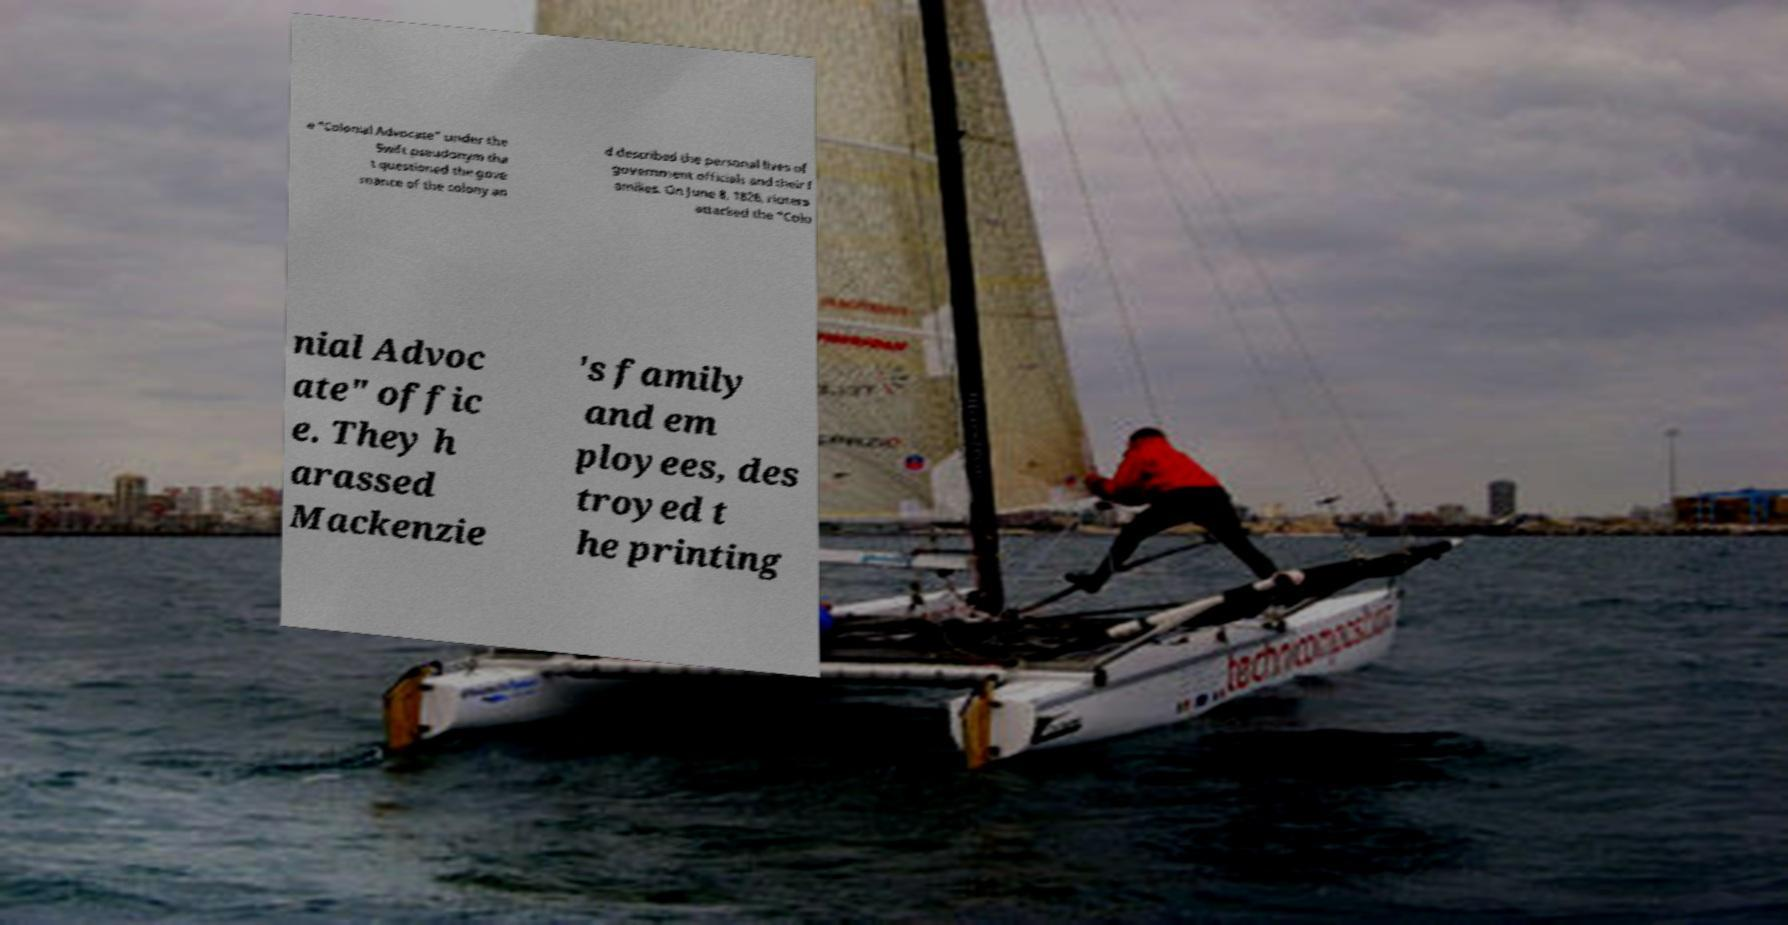What messages or text are displayed in this image? I need them in a readable, typed format. e "Colonial Advocate" under the Swift pseudonym tha t questioned the gove rnance of the colony an d described the personal lives of government officials and their f amilies. On June 8, 1826, rioters attacked the "Colo nial Advoc ate" offic e. They h arassed Mackenzie 's family and em ployees, des troyed t he printing 